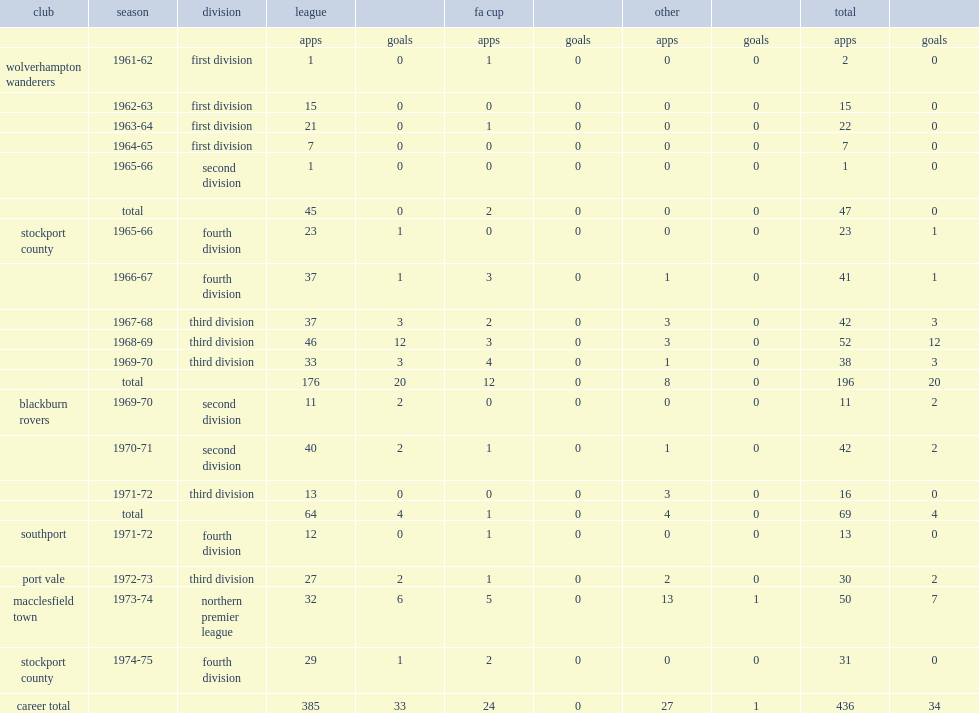Which club did freddie goodwin play for in 1966-67? Stockport county. 